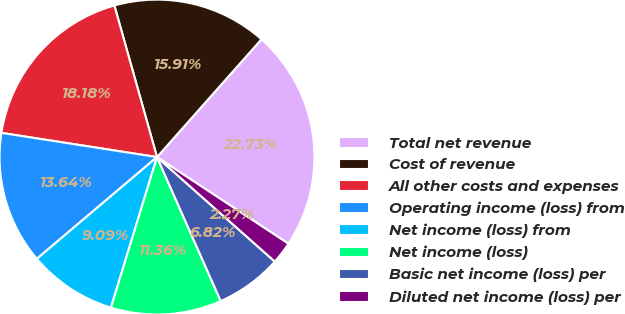Convert chart to OTSL. <chart><loc_0><loc_0><loc_500><loc_500><pie_chart><fcel>Total net revenue<fcel>Cost of revenue<fcel>All other costs and expenses<fcel>Operating income (loss) from<fcel>Net income (loss) from<fcel>Net income (loss)<fcel>Basic net income (loss) per<fcel>Diluted net income (loss) per<nl><fcel>22.73%<fcel>15.91%<fcel>18.18%<fcel>13.64%<fcel>9.09%<fcel>11.36%<fcel>6.82%<fcel>2.27%<nl></chart> 